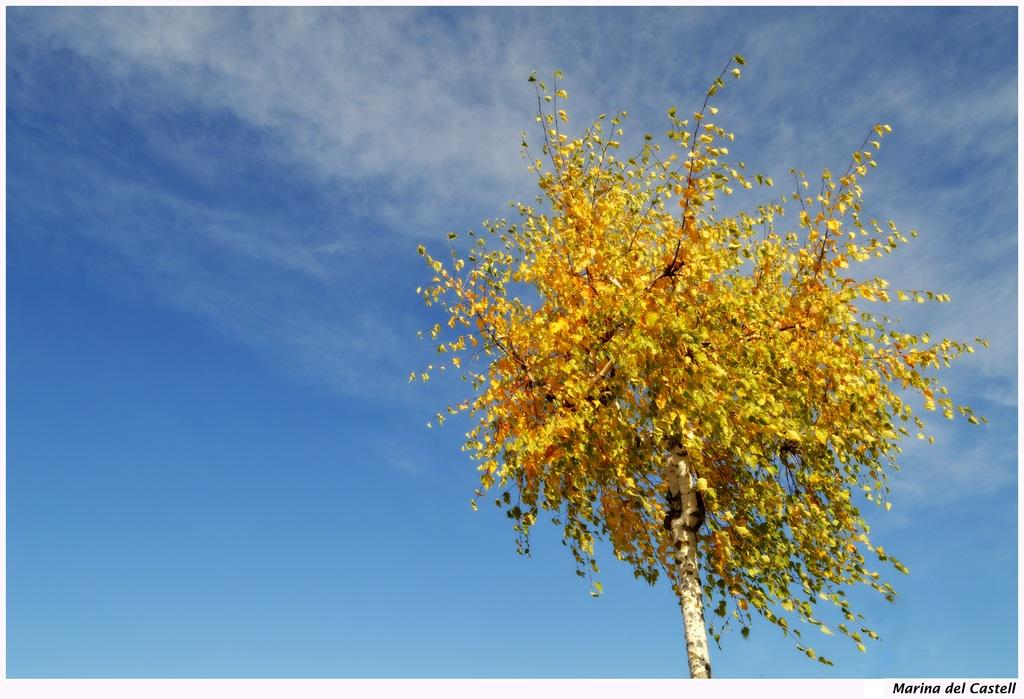What is the main subject in the picture? There is a tree in the picture. What is the color of the tree? The tree is in yellow color. What can be seen in the background of the picture? The sky is visible in the background of the picture. What is the color of the sky? The sky is blue in color. Is there a yard in the picture where people can find peace? There is no mention of a yard or peace in the image; it only features a yellow tree and a blue sky. 